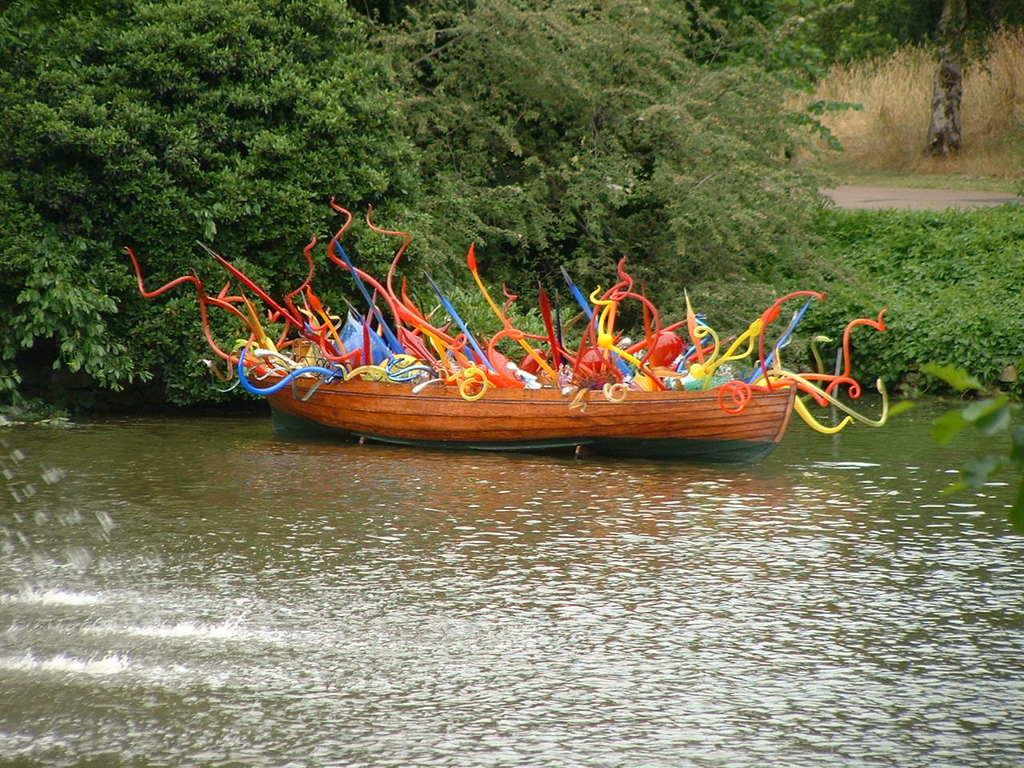What is the main subject of the image? The main subject of the image is a boat. What is the boat doing in the image? The boat is floating on the water. What can be seen in the middle of the image besides the boat? There are trees and plants in the middle of the image. Where is the stem located in the image? The stem is in the top right of the image. What type of ghost can be seen haunting the boat in the image? There is no ghost present in the image; it only features a boat floating on the water, trees, plants, and a stem. What color is the paint used on the boat in the image? There is no information about the color of the paint used on the boat in the image, as the facts provided do not mention it. 